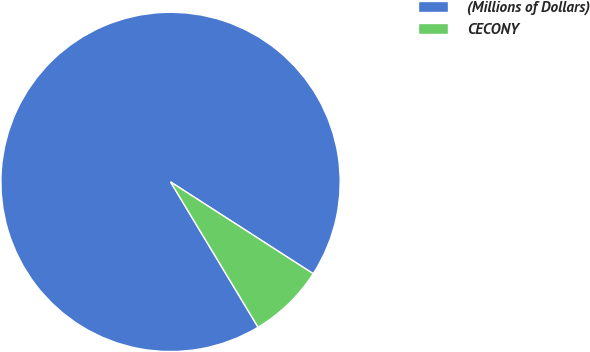Convert chart to OTSL. <chart><loc_0><loc_0><loc_500><loc_500><pie_chart><fcel>(Millions of Dollars)<fcel>CECONY<nl><fcel>92.73%<fcel>7.27%<nl></chart> 